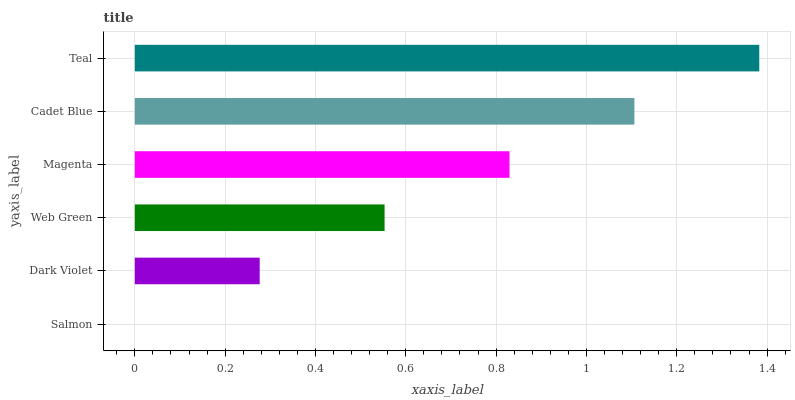Is Salmon the minimum?
Answer yes or no. Yes. Is Teal the maximum?
Answer yes or no. Yes. Is Dark Violet the minimum?
Answer yes or no. No. Is Dark Violet the maximum?
Answer yes or no. No. Is Dark Violet greater than Salmon?
Answer yes or no. Yes. Is Salmon less than Dark Violet?
Answer yes or no. Yes. Is Salmon greater than Dark Violet?
Answer yes or no. No. Is Dark Violet less than Salmon?
Answer yes or no. No. Is Magenta the high median?
Answer yes or no. Yes. Is Web Green the low median?
Answer yes or no. Yes. Is Salmon the high median?
Answer yes or no. No. Is Salmon the low median?
Answer yes or no. No. 